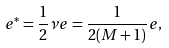<formula> <loc_0><loc_0><loc_500><loc_500>e ^ { * } = \frac { 1 } { 2 } \nu e = \frac { 1 } { 2 ( M + 1 ) } e ,</formula> 